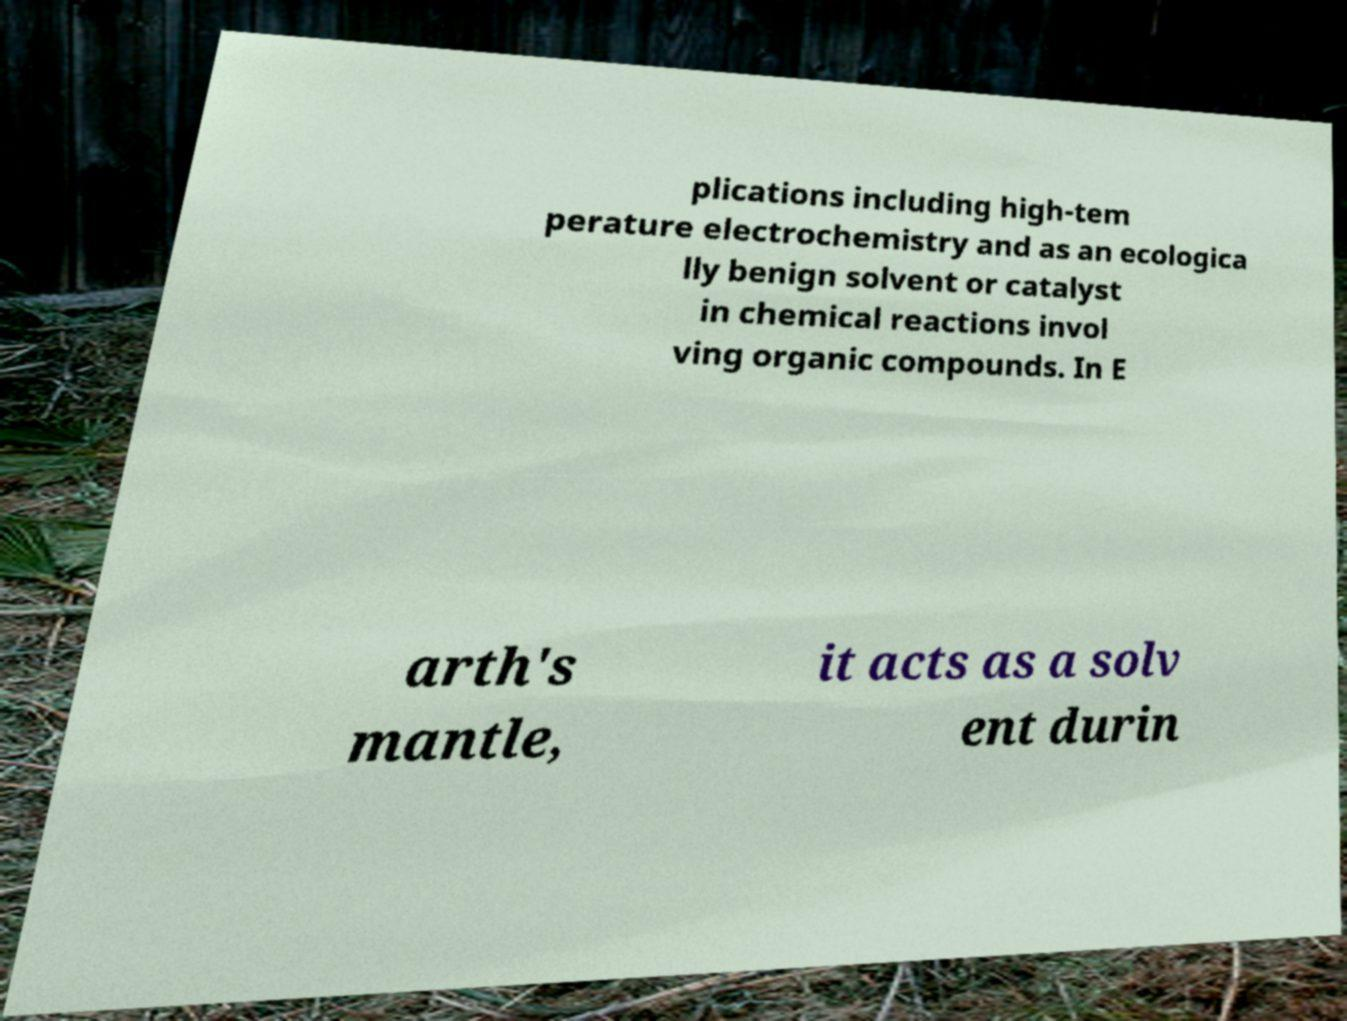I need the written content from this picture converted into text. Can you do that? plications including high-tem perature electrochemistry and as an ecologica lly benign solvent or catalyst in chemical reactions invol ving organic compounds. In E arth's mantle, it acts as a solv ent durin 